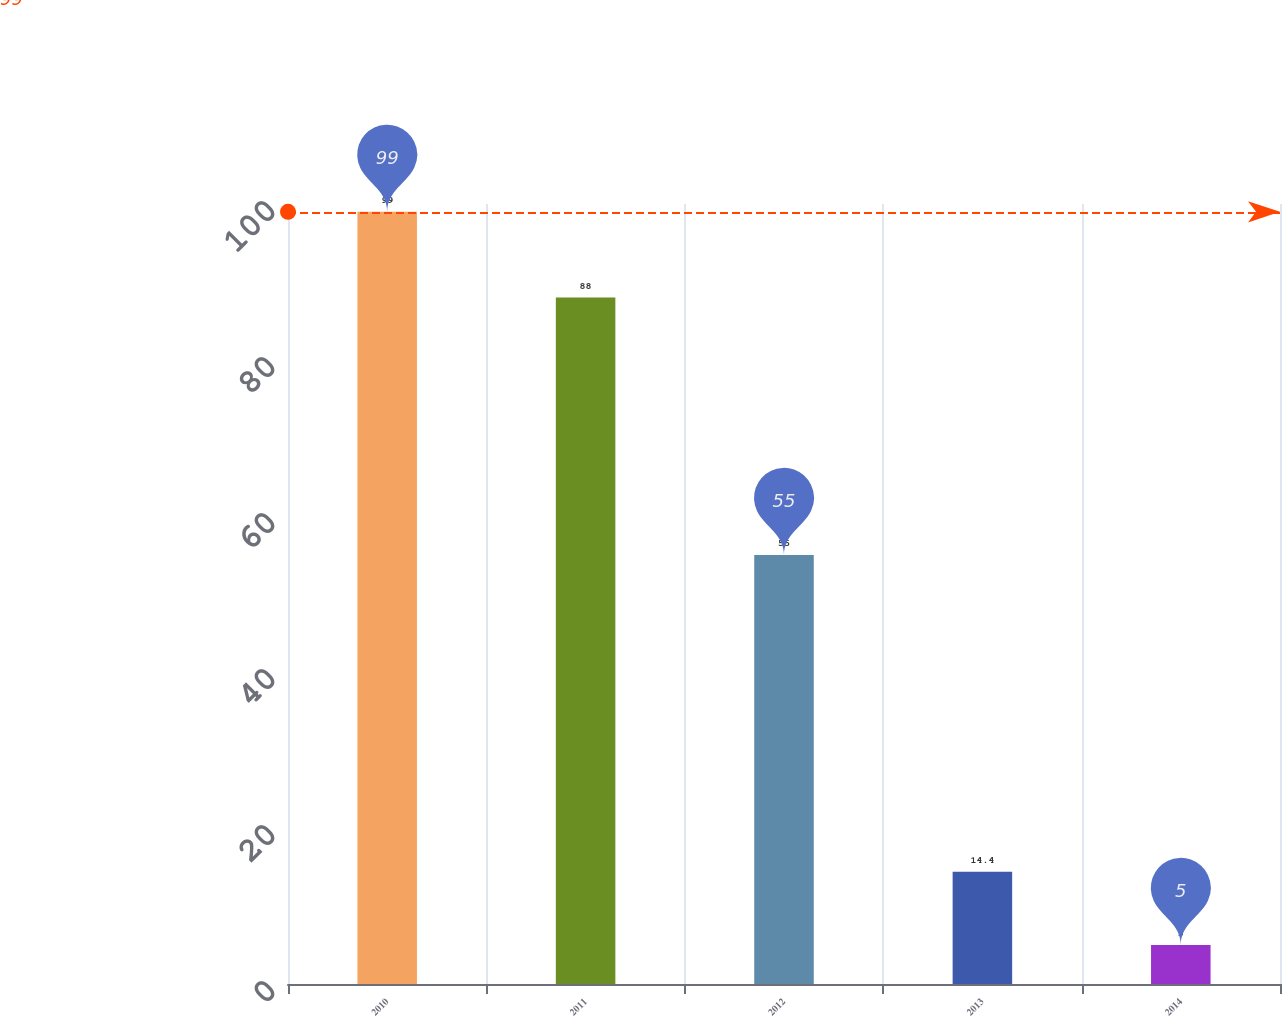<chart> <loc_0><loc_0><loc_500><loc_500><bar_chart><fcel>2010<fcel>2011<fcel>2012<fcel>2013<fcel>2014<nl><fcel>99<fcel>88<fcel>55<fcel>14.4<fcel>5<nl></chart> 